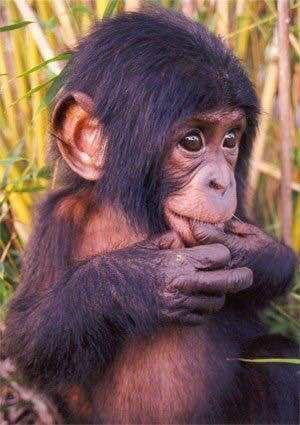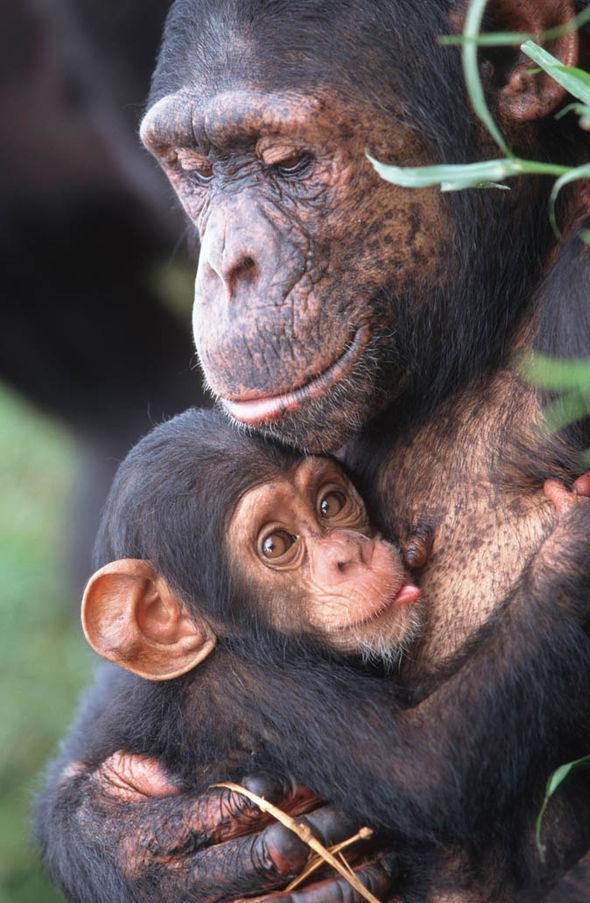The first image is the image on the left, the second image is the image on the right. Considering the images on both sides, is "A mother and a baby ape is pictured on the right image." valid? Answer yes or no. Yes. 